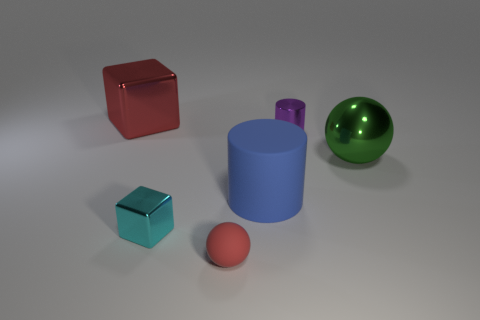Add 1 green metallic spheres. How many objects exist? 7 Subtract all balls. How many objects are left? 4 Subtract all large green metal balls. Subtract all cyan objects. How many objects are left? 4 Add 4 big blue cylinders. How many big blue cylinders are left? 5 Add 4 tiny red objects. How many tiny red objects exist? 5 Subtract 0 brown spheres. How many objects are left? 6 